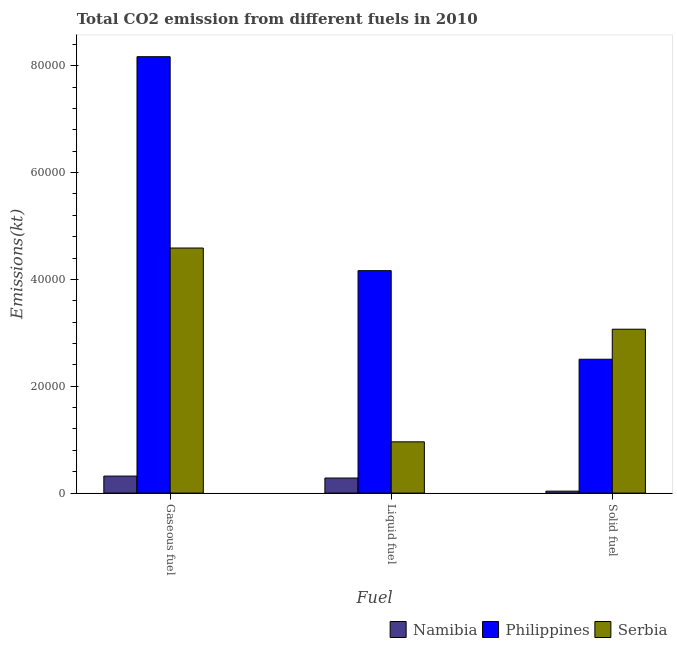How many groups of bars are there?
Make the answer very short. 3. Are the number of bars per tick equal to the number of legend labels?
Keep it short and to the point. Yes. How many bars are there on the 2nd tick from the right?
Provide a short and direct response. 3. What is the label of the 3rd group of bars from the left?
Your response must be concise. Solid fuel. What is the amount of co2 emissions from solid fuel in Namibia?
Offer a very short reply. 359.37. Across all countries, what is the maximum amount of co2 emissions from solid fuel?
Your answer should be compact. 3.07e+04. Across all countries, what is the minimum amount of co2 emissions from gaseous fuel?
Your answer should be very brief. 3179.29. In which country was the amount of co2 emissions from liquid fuel maximum?
Give a very brief answer. Philippines. In which country was the amount of co2 emissions from liquid fuel minimum?
Your answer should be very brief. Namibia. What is the total amount of co2 emissions from solid fuel in the graph?
Provide a succinct answer. 5.61e+04. What is the difference between the amount of co2 emissions from liquid fuel in Philippines and that in Serbia?
Give a very brief answer. 3.20e+04. What is the difference between the amount of co2 emissions from gaseous fuel in Namibia and the amount of co2 emissions from liquid fuel in Serbia?
Provide a succinct answer. -6413.58. What is the average amount of co2 emissions from solid fuel per country?
Offer a very short reply. 1.87e+04. What is the difference between the amount of co2 emissions from liquid fuel and amount of co2 emissions from gaseous fuel in Namibia?
Keep it short and to the point. -363.03. In how many countries, is the amount of co2 emissions from solid fuel greater than 72000 kt?
Your response must be concise. 0. What is the ratio of the amount of co2 emissions from gaseous fuel in Philippines to that in Serbia?
Your response must be concise. 1.78. Is the amount of co2 emissions from liquid fuel in Philippines less than that in Namibia?
Give a very brief answer. No. What is the difference between the highest and the second highest amount of co2 emissions from liquid fuel?
Provide a succinct answer. 3.20e+04. What is the difference between the highest and the lowest amount of co2 emissions from solid fuel?
Ensure brevity in your answer.  3.03e+04. In how many countries, is the amount of co2 emissions from gaseous fuel greater than the average amount of co2 emissions from gaseous fuel taken over all countries?
Your answer should be compact. 2. What does the 1st bar from the left in Gaseous fuel represents?
Provide a short and direct response. Namibia. What does the 2nd bar from the right in Gaseous fuel represents?
Make the answer very short. Philippines. Are all the bars in the graph horizontal?
Give a very brief answer. No. How many countries are there in the graph?
Keep it short and to the point. 3. What is the difference between two consecutive major ticks on the Y-axis?
Make the answer very short. 2.00e+04. Are the values on the major ticks of Y-axis written in scientific E-notation?
Your answer should be compact. No. How are the legend labels stacked?
Your answer should be very brief. Horizontal. What is the title of the graph?
Provide a succinct answer. Total CO2 emission from different fuels in 2010. What is the label or title of the X-axis?
Your answer should be compact. Fuel. What is the label or title of the Y-axis?
Your response must be concise. Emissions(kt). What is the Emissions(kt) in Namibia in Gaseous fuel?
Provide a succinct answer. 3179.29. What is the Emissions(kt) of Philippines in Gaseous fuel?
Make the answer very short. 8.17e+04. What is the Emissions(kt) of Serbia in Gaseous fuel?
Make the answer very short. 4.59e+04. What is the Emissions(kt) in Namibia in Liquid fuel?
Your answer should be very brief. 2816.26. What is the Emissions(kt) in Philippines in Liquid fuel?
Ensure brevity in your answer.  4.16e+04. What is the Emissions(kt) in Serbia in Liquid fuel?
Ensure brevity in your answer.  9592.87. What is the Emissions(kt) in Namibia in Solid fuel?
Provide a short and direct response. 359.37. What is the Emissions(kt) of Philippines in Solid fuel?
Provide a succinct answer. 2.51e+04. What is the Emissions(kt) in Serbia in Solid fuel?
Provide a short and direct response. 3.07e+04. Across all Fuel, what is the maximum Emissions(kt) in Namibia?
Provide a short and direct response. 3179.29. Across all Fuel, what is the maximum Emissions(kt) in Philippines?
Make the answer very short. 8.17e+04. Across all Fuel, what is the maximum Emissions(kt) in Serbia?
Your answer should be very brief. 4.59e+04. Across all Fuel, what is the minimum Emissions(kt) in Namibia?
Provide a succinct answer. 359.37. Across all Fuel, what is the minimum Emissions(kt) in Philippines?
Provide a succinct answer. 2.51e+04. Across all Fuel, what is the minimum Emissions(kt) of Serbia?
Give a very brief answer. 9592.87. What is the total Emissions(kt) in Namibia in the graph?
Your answer should be compact. 6354.91. What is the total Emissions(kt) of Philippines in the graph?
Give a very brief answer. 1.48e+05. What is the total Emissions(kt) in Serbia in the graph?
Provide a succinct answer. 8.61e+04. What is the difference between the Emissions(kt) in Namibia in Gaseous fuel and that in Liquid fuel?
Provide a short and direct response. 363.03. What is the difference between the Emissions(kt) in Philippines in Gaseous fuel and that in Liquid fuel?
Provide a succinct answer. 4.01e+04. What is the difference between the Emissions(kt) in Serbia in Gaseous fuel and that in Liquid fuel?
Your answer should be very brief. 3.63e+04. What is the difference between the Emissions(kt) in Namibia in Gaseous fuel and that in Solid fuel?
Ensure brevity in your answer.  2819.92. What is the difference between the Emissions(kt) of Philippines in Gaseous fuel and that in Solid fuel?
Offer a very short reply. 5.66e+04. What is the difference between the Emissions(kt) in Serbia in Gaseous fuel and that in Solid fuel?
Your answer should be very brief. 1.52e+04. What is the difference between the Emissions(kt) in Namibia in Liquid fuel and that in Solid fuel?
Give a very brief answer. 2456.89. What is the difference between the Emissions(kt) of Philippines in Liquid fuel and that in Solid fuel?
Make the answer very short. 1.66e+04. What is the difference between the Emissions(kt) in Serbia in Liquid fuel and that in Solid fuel?
Ensure brevity in your answer.  -2.11e+04. What is the difference between the Emissions(kt) of Namibia in Gaseous fuel and the Emissions(kt) of Philippines in Liquid fuel?
Your answer should be very brief. -3.85e+04. What is the difference between the Emissions(kt) of Namibia in Gaseous fuel and the Emissions(kt) of Serbia in Liquid fuel?
Your response must be concise. -6413.58. What is the difference between the Emissions(kt) of Philippines in Gaseous fuel and the Emissions(kt) of Serbia in Liquid fuel?
Your answer should be very brief. 7.21e+04. What is the difference between the Emissions(kt) in Namibia in Gaseous fuel and the Emissions(kt) in Philippines in Solid fuel?
Make the answer very short. -2.19e+04. What is the difference between the Emissions(kt) of Namibia in Gaseous fuel and the Emissions(kt) of Serbia in Solid fuel?
Offer a very short reply. -2.75e+04. What is the difference between the Emissions(kt) in Philippines in Gaseous fuel and the Emissions(kt) in Serbia in Solid fuel?
Offer a terse response. 5.10e+04. What is the difference between the Emissions(kt) in Namibia in Liquid fuel and the Emissions(kt) in Philippines in Solid fuel?
Ensure brevity in your answer.  -2.22e+04. What is the difference between the Emissions(kt) of Namibia in Liquid fuel and the Emissions(kt) of Serbia in Solid fuel?
Keep it short and to the point. -2.79e+04. What is the difference between the Emissions(kt) of Philippines in Liquid fuel and the Emissions(kt) of Serbia in Solid fuel?
Provide a short and direct response. 1.10e+04. What is the average Emissions(kt) of Namibia per Fuel?
Offer a terse response. 2118.3. What is the average Emissions(kt) in Philippines per Fuel?
Make the answer very short. 4.95e+04. What is the average Emissions(kt) of Serbia per Fuel?
Your answer should be compact. 2.87e+04. What is the difference between the Emissions(kt) in Namibia and Emissions(kt) in Philippines in Gaseous fuel?
Ensure brevity in your answer.  -7.85e+04. What is the difference between the Emissions(kt) in Namibia and Emissions(kt) in Serbia in Gaseous fuel?
Offer a terse response. -4.27e+04. What is the difference between the Emissions(kt) of Philippines and Emissions(kt) of Serbia in Gaseous fuel?
Offer a very short reply. 3.58e+04. What is the difference between the Emissions(kt) in Namibia and Emissions(kt) in Philippines in Liquid fuel?
Provide a succinct answer. -3.88e+04. What is the difference between the Emissions(kt) of Namibia and Emissions(kt) of Serbia in Liquid fuel?
Give a very brief answer. -6776.62. What is the difference between the Emissions(kt) of Philippines and Emissions(kt) of Serbia in Liquid fuel?
Provide a short and direct response. 3.20e+04. What is the difference between the Emissions(kt) of Namibia and Emissions(kt) of Philippines in Solid fuel?
Your response must be concise. -2.47e+04. What is the difference between the Emissions(kt) of Namibia and Emissions(kt) of Serbia in Solid fuel?
Ensure brevity in your answer.  -3.03e+04. What is the difference between the Emissions(kt) in Philippines and Emissions(kt) in Serbia in Solid fuel?
Offer a terse response. -5621.51. What is the ratio of the Emissions(kt) in Namibia in Gaseous fuel to that in Liquid fuel?
Ensure brevity in your answer.  1.13. What is the ratio of the Emissions(kt) of Philippines in Gaseous fuel to that in Liquid fuel?
Provide a succinct answer. 1.96. What is the ratio of the Emissions(kt) in Serbia in Gaseous fuel to that in Liquid fuel?
Offer a very short reply. 4.78. What is the ratio of the Emissions(kt) in Namibia in Gaseous fuel to that in Solid fuel?
Make the answer very short. 8.85. What is the ratio of the Emissions(kt) in Philippines in Gaseous fuel to that in Solid fuel?
Offer a very short reply. 3.26. What is the ratio of the Emissions(kt) of Serbia in Gaseous fuel to that in Solid fuel?
Offer a very short reply. 1.5. What is the ratio of the Emissions(kt) in Namibia in Liquid fuel to that in Solid fuel?
Your response must be concise. 7.84. What is the ratio of the Emissions(kt) in Philippines in Liquid fuel to that in Solid fuel?
Offer a terse response. 1.66. What is the ratio of the Emissions(kt) of Serbia in Liquid fuel to that in Solid fuel?
Offer a terse response. 0.31. What is the difference between the highest and the second highest Emissions(kt) in Namibia?
Ensure brevity in your answer.  363.03. What is the difference between the highest and the second highest Emissions(kt) in Philippines?
Offer a very short reply. 4.01e+04. What is the difference between the highest and the second highest Emissions(kt) of Serbia?
Your answer should be compact. 1.52e+04. What is the difference between the highest and the lowest Emissions(kt) in Namibia?
Offer a terse response. 2819.92. What is the difference between the highest and the lowest Emissions(kt) of Philippines?
Offer a very short reply. 5.66e+04. What is the difference between the highest and the lowest Emissions(kt) of Serbia?
Offer a very short reply. 3.63e+04. 